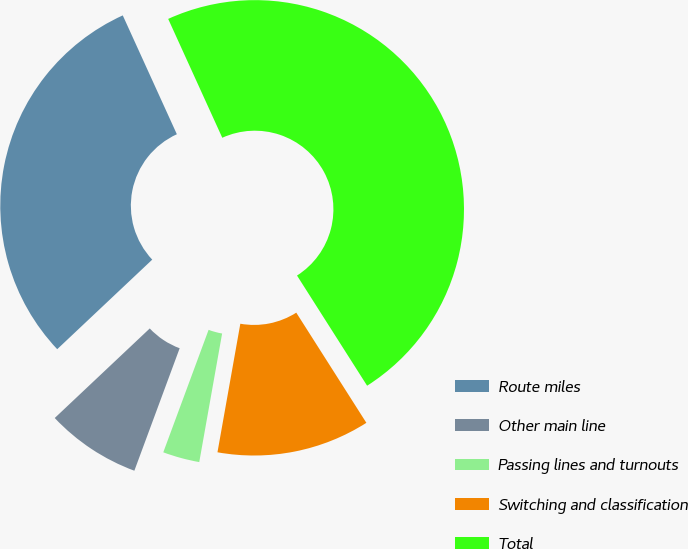Convert chart. <chart><loc_0><loc_0><loc_500><loc_500><pie_chart><fcel>Route miles<fcel>Other main line<fcel>Passing lines and turnouts<fcel>Switching and classification<fcel>Total<nl><fcel>30.23%<fcel>7.33%<fcel>2.84%<fcel>11.82%<fcel>47.78%<nl></chart> 